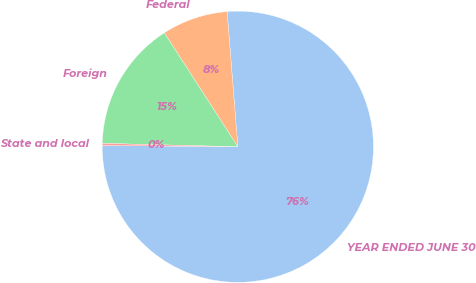Convert chart to OTSL. <chart><loc_0><loc_0><loc_500><loc_500><pie_chart><fcel>YEAR ENDED JUNE 30<fcel>Federal<fcel>Foreign<fcel>State and local<nl><fcel>76.41%<fcel>7.86%<fcel>15.48%<fcel>0.25%<nl></chart> 